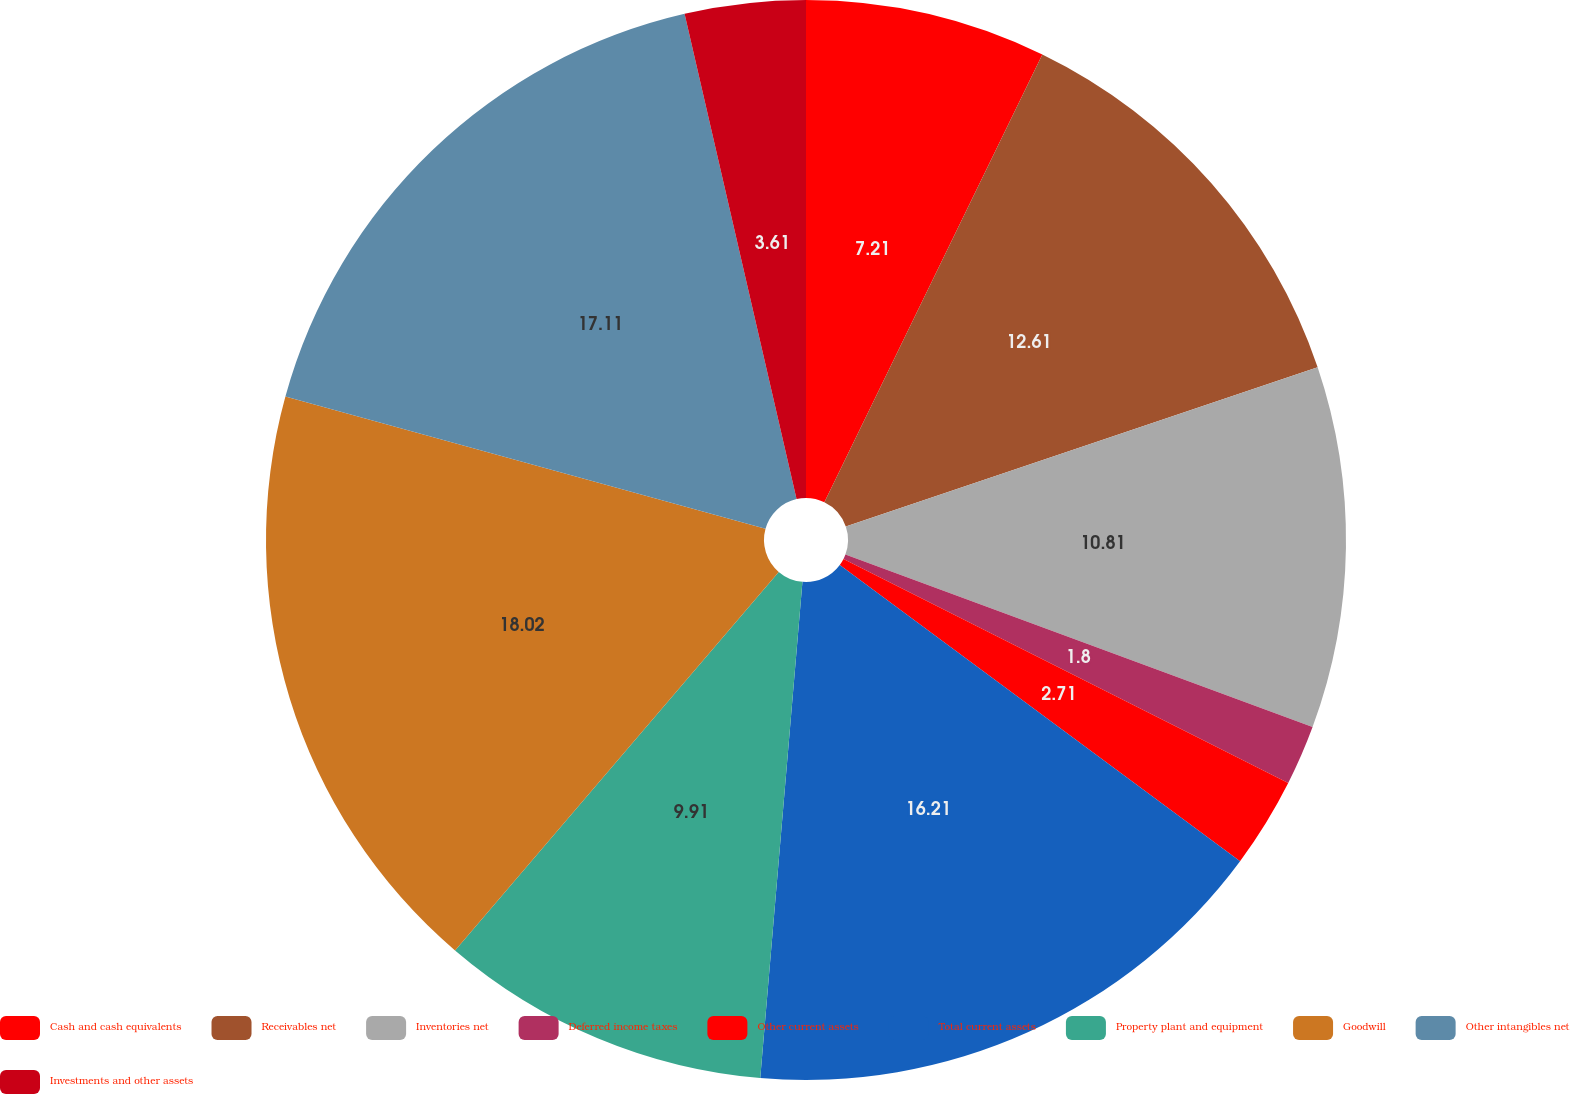Convert chart. <chart><loc_0><loc_0><loc_500><loc_500><pie_chart><fcel>Cash and cash equivalents<fcel>Receivables net<fcel>Inventories net<fcel>Deferred income taxes<fcel>Other current assets<fcel>Total current assets<fcel>Property plant and equipment<fcel>Goodwill<fcel>Other intangibles net<fcel>Investments and other assets<nl><fcel>7.21%<fcel>12.61%<fcel>10.81%<fcel>1.8%<fcel>2.71%<fcel>16.21%<fcel>9.91%<fcel>18.02%<fcel>17.11%<fcel>3.61%<nl></chart> 